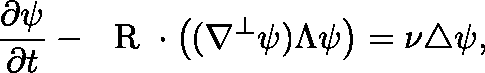<formula> <loc_0><loc_0><loc_500><loc_500>\frac { \partial \psi } { \partial t } - \boldmath R \cdot \left ( ( \nabla ^ { \perp } \psi ) \Lambda \psi \right ) = \nu \triangle \psi ,</formula> 